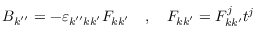<formula> <loc_0><loc_0><loc_500><loc_500>\begin{array} { r } { B _ { k ^ { \prime \prime } } = - \varepsilon _ { k ^ { \prime \prime } k k ^ { \prime } } F _ { k k ^ { \prime } } \quad , \quad F _ { k k ^ { \prime } } = F _ { k k ^ { \prime } } ^ { j } t ^ { j } } \end{array}</formula> 